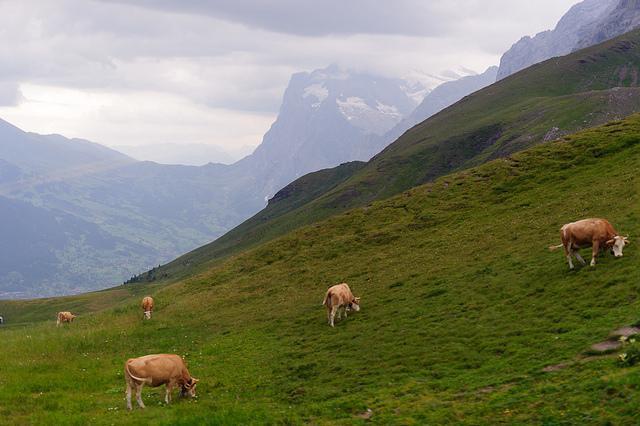How many cows can you see?
Give a very brief answer. 2. 